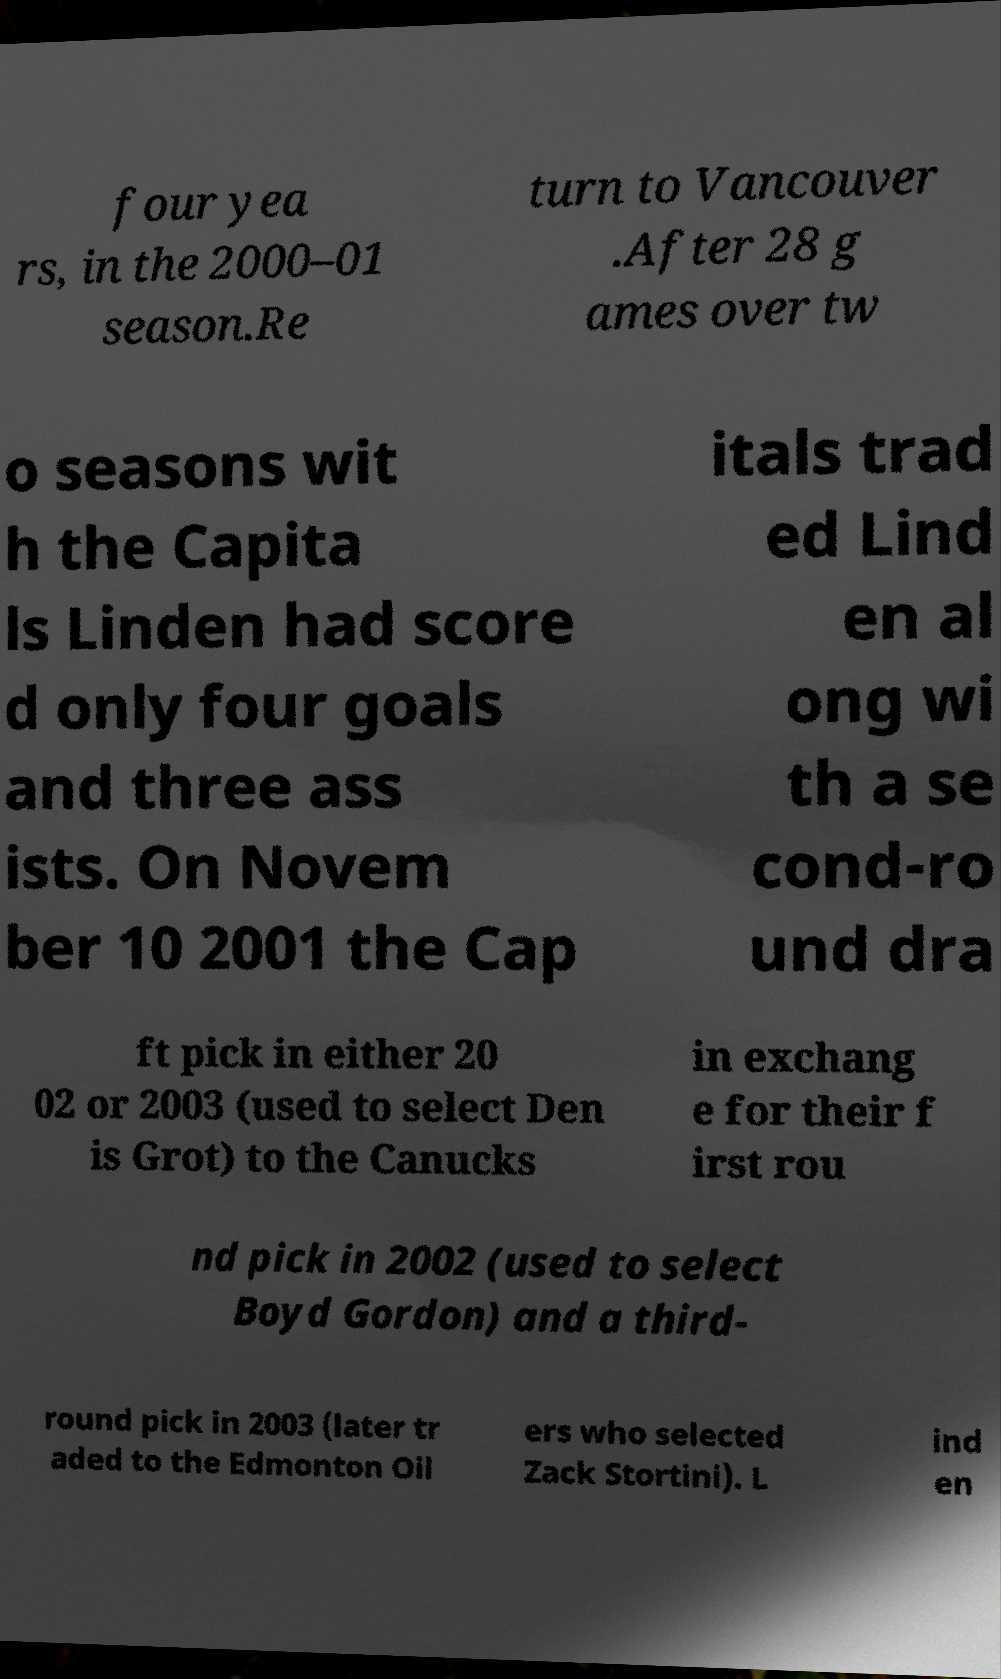What messages or text are displayed in this image? I need them in a readable, typed format. four yea rs, in the 2000–01 season.Re turn to Vancouver .After 28 g ames over tw o seasons wit h the Capita ls Linden had score d only four goals and three ass ists. On Novem ber 10 2001 the Cap itals trad ed Lind en al ong wi th a se cond-ro und dra ft pick in either 20 02 or 2003 (used to select Den is Grot) to the Canucks in exchang e for their f irst rou nd pick in 2002 (used to select Boyd Gordon) and a third- round pick in 2003 (later tr aded to the Edmonton Oil ers who selected Zack Stortini). L ind en 